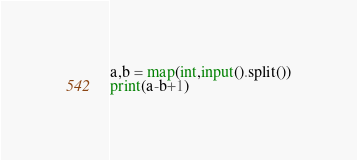<code> <loc_0><loc_0><loc_500><loc_500><_Python_>a,b = map(int,input().split())
print(a-b+1)</code> 